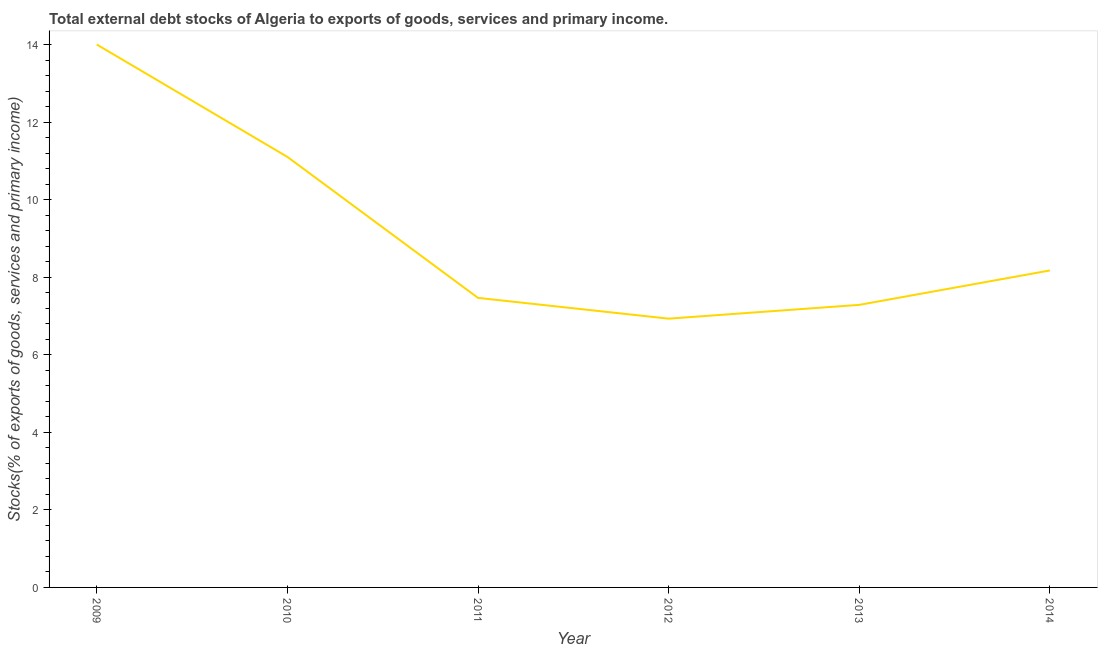What is the external debt stocks in 2013?
Make the answer very short. 7.29. Across all years, what is the maximum external debt stocks?
Your answer should be compact. 14. Across all years, what is the minimum external debt stocks?
Give a very brief answer. 6.93. In which year was the external debt stocks minimum?
Provide a short and direct response. 2012. What is the sum of the external debt stocks?
Give a very brief answer. 54.96. What is the difference between the external debt stocks in 2009 and 2011?
Your answer should be very brief. 6.53. What is the average external debt stocks per year?
Keep it short and to the point. 9.16. What is the median external debt stocks?
Keep it short and to the point. 7.82. What is the ratio of the external debt stocks in 2012 to that in 2013?
Keep it short and to the point. 0.95. Is the external debt stocks in 2009 less than that in 2013?
Make the answer very short. No. What is the difference between the highest and the second highest external debt stocks?
Your answer should be very brief. 2.9. What is the difference between the highest and the lowest external debt stocks?
Provide a short and direct response. 7.07. In how many years, is the external debt stocks greater than the average external debt stocks taken over all years?
Make the answer very short. 2. Does the external debt stocks monotonically increase over the years?
Offer a very short reply. No. What is the difference between two consecutive major ticks on the Y-axis?
Keep it short and to the point. 2. Are the values on the major ticks of Y-axis written in scientific E-notation?
Your answer should be compact. No. What is the title of the graph?
Keep it short and to the point. Total external debt stocks of Algeria to exports of goods, services and primary income. What is the label or title of the X-axis?
Keep it short and to the point. Year. What is the label or title of the Y-axis?
Keep it short and to the point. Stocks(% of exports of goods, services and primary income). What is the Stocks(% of exports of goods, services and primary income) in 2009?
Provide a succinct answer. 14. What is the Stocks(% of exports of goods, services and primary income) of 2010?
Ensure brevity in your answer.  11.1. What is the Stocks(% of exports of goods, services and primary income) in 2011?
Make the answer very short. 7.47. What is the Stocks(% of exports of goods, services and primary income) of 2012?
Offer a very short reply. 6.93. What is the Stocks(% of exports of goods, services and primary income) of 2013?
Ensure brevity in your answer.  7.29. What is the Stocks(% of exports of goods, services and primary income) in 2014?
Ensure brevity in your answer.  8.17. What is the difference between the Stocks(% of exports of goods, services and primary income) in 2009 and 2010?
Offer a very short reply. 2.9. What is the difference between the Stocks(% of exports of goods, services and primary income) in 2009 and 2011?
Your answer should be very brief. 6.53. What is the difference between the Stocks(% of exports of goods, services and primary income) in 2009 and 2012?
Your response must be concise. 7.07. What is the difference between the Stocks(% of exports of goods, services and primary income) in 2009 and 2013?
Make the answer very short. 6.71. What is the difference between the Stocks(% of exports of goods, services and primary income) in 2009 and 2014?
Your response must be concise. 5.83. What is the difference between the Stocks(% of exports of goods, services and primary income) in 2010 and 2011?
Keep it short and to the point. 3.64. What is the difference between the Stocks(% of exports of goods, services and primary income) in 2010 and 2012?
Give a very brief answer. 4.17. What is the difference between the Stocks(% of exports of goods, services and primary income) in 2010 and 2013?
Provide a short and direct response. 3.82. What is the difference between the Stocks(% of exports of goods, services and primary income) in 2010 and 2014?
Your answer should be compact. 2.93. What is the difference between the Stocks(% of exports of goods, services and primary income) in 2011 and 2012?
Your answer should be very brief. 0.54. What is the difference between the Stocks(% of exports of goods, services and primary income) in 2011 and 2013?
Your answer should be compact. 0.18. What is the difference between the Stocks(% of exports of goods, services and primary income) in 2011 and 2014?
Offer a terse response. -0.71. What is the difference between the Stocks(% of exports of goods, services and primary income) in 2012 and 2013?
Your answer should be very brief. -0.36. What is the difference between the Stocks(% of exports of goods, services and primary income) in 2012 and 2014?
Provide a short and direct response. -1.24. What is the difference between the Stocks(% of exports of goods, services and primary income) in 2013 and 2014?
Make the answer very short. -0.89. What is the ratio of the Stocks(% of exports of goods, services and primary income) in 2009 to that in 2010?
Offer a very short reply. 1.26. What is the ratio of the Stocks(% of exports of goods, services and primary income) in 2009 to that in 2011?
Your answer should be very brief. 1.88. What is the ratio of the Stocks(% of exports of goods, services and primary income) in 2009 to that in 2012?
Offer a terse response. 2.02. What is the ratio of the Stocks(% of exports of goods, services and primary income) in 2009 to that in 2013?
Provide a succinct answer. 1.92. What is the ratio of the Stocks(% of exports of goods, services and primary income) in 2009 to that in 2014?
Your response must be concise. 1.71. What is the ratio of the Stocks(% of exports of goods, services and primary income) in 2010 to that in 2011?
Make the answer very short. 1.49. What is the ratio of the Stocks(% of exports of goods, services and primary income) in 2010 to that in 2012?
Ensure brevity in your answer.  1.6. What is the ratio of the Stocks(% of exports of goods, services and primary income) in 2010 to that in 2013?
Offer a very short reply. 1.52. What is the ratio of the Stocks(% of exports of goods, services and primary income) in 2010 to that in 2014?
Provide a short and direct response. 1.36. What is the ratio of the Stocks(% of exports of goods, services and primary income) in 2011 to that in 2012?
Your answer should be very brief. 1.08. What is the ratio of the Stocks(% of exports of goods, services and primary income) in 2011 to that in 2014?
Your answer should be compact. 0.91. What is the ratio of the Stocks(% of exports of goods, services and primary income) in 2012 to that in 2013?
Ensure brevity in your answer.  0.95. What is the ratio of the Stocks(% of exports of goods, services and primary income) in 2012 to that in 2014?
Provide a succinct answer. 0.85. What is the ratio of the Stocks(% of exports of goods, services and primary income) in 2013 to that in 2014?
Provide a succinct answer. 0.89. 